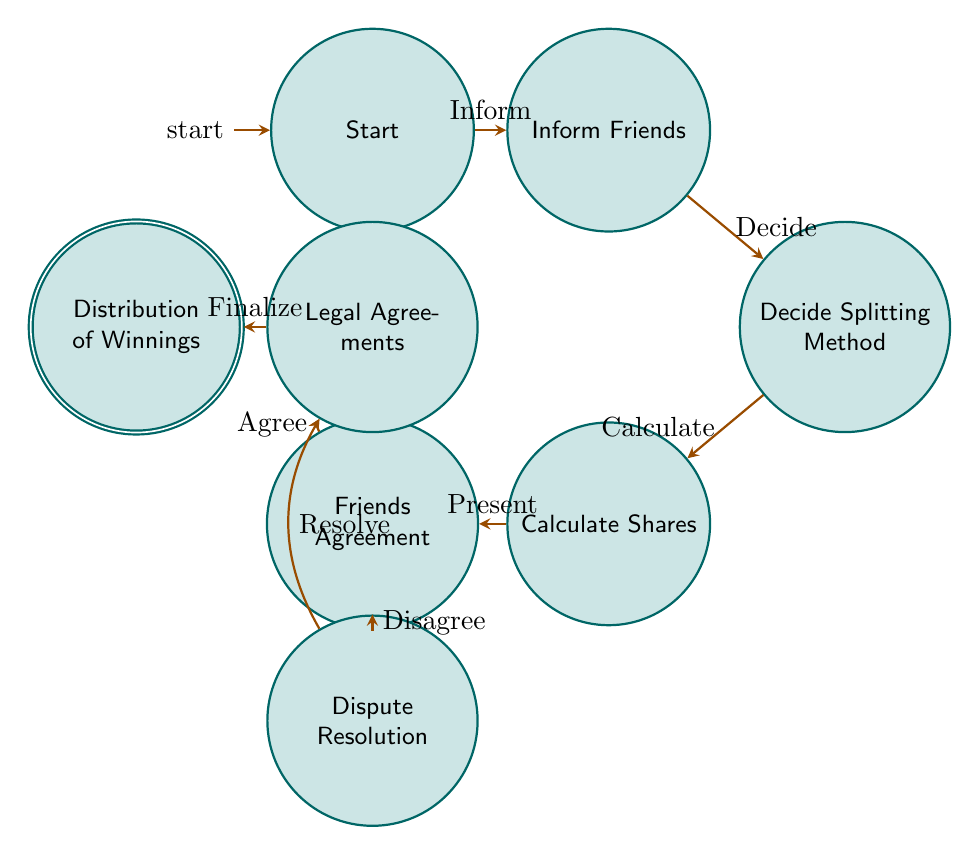What is the initial state in the diagram? The initial state is labeled "Start." It is the first node that the flow of the diagram begins from, indicating where the lottery enthusiast starts the decision-making process.
Answer: Start How many states are there in total? By counting all the nodes in the diagram, we can see that there are eight distinct states present in the flow.
Answer: Eight What follows after "Calculate Shares"? The next state that follows "Calculate Shares" is "Friends Agreement," which indicates the next action after the winnings have been calculated.
Answer: Friends Agreement What is required for the transition from "Friends Agreement" to "Legal Agreements"? A condition is specified: the transition occurs if the friends "agree" on the share calculations, indicating that their consensus is necessary for this step.
Answer: Agree What happens if friends disagree on the shares? If the friends disagree, the flow moves to the state called "Dispute Resolution," where disagreements are handled before progressing further.
Answer: Dispute Resolution What is the final state in this Finite State Machine? The last state, which represents the end of the process, is "Distribution of Winnings.” This is where the winnings are distributed based on the agreements reached.
Answer: Distribution of Winnings How does the "Distribution of Winnings" state relate to "Legal Agreements"? The relationship shows that "Distribution of Winnings" occurs after the "Legal Agreements" state, meaning that finalizing legal documents is necessary before winnings are distributed.
Answer: Finalize In the diagram, how many transitions lead out of the "Friends Agreement" state? There are two transitions leading out of the "Friends Agreement" state: one leads to "Legal Agreements" if they agree, and the other leads to "Dispute Resolution" if they disagree.
Answer: Two 